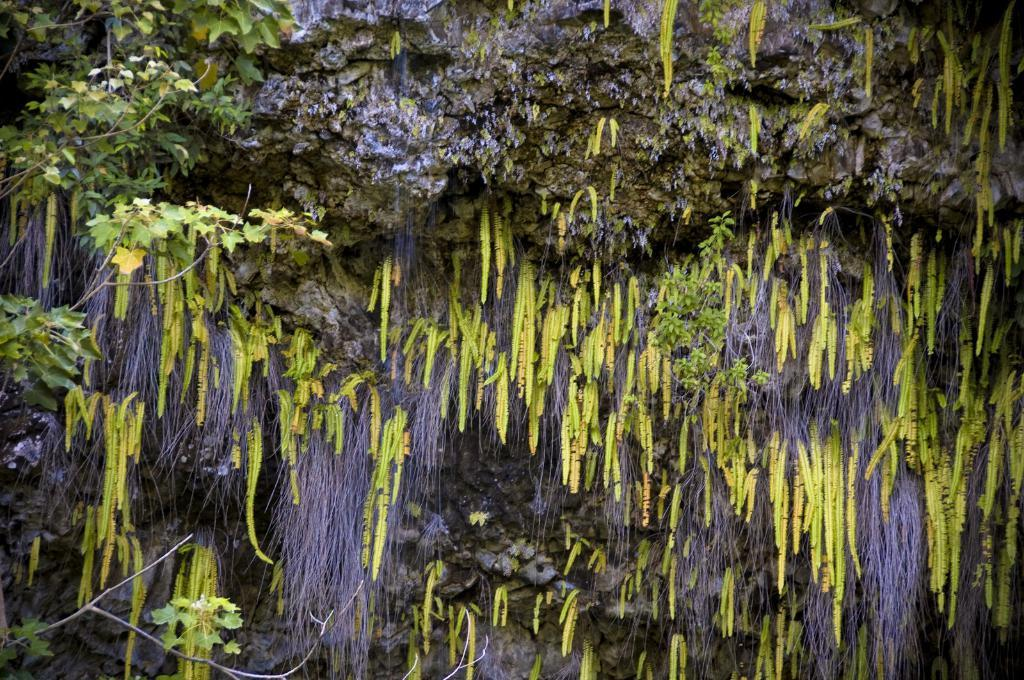What type of vegetation can be seen in the image? There are trees in the image. Can you describe the trees in the image? The provided facts do not include specific details about the trees, so we cannot describe them further. What type of request is being made in the image? There is no request present in the image; it only features trees. Can you tell me where the oven is located in the image? There is no oven present in the image; it only features trees. 